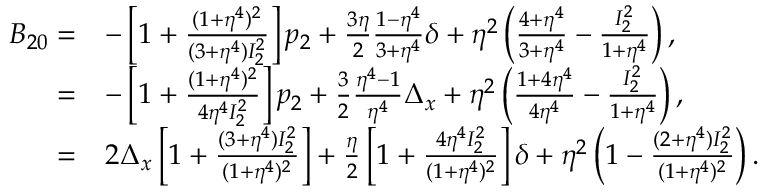Convert formula to latex. <formula><loc_0><loc_0><loc_500><loc_500>\begin{array} { r l } { B _ { 2 0 } = } & { - \left [ 1 + \frac { ( 1 + \eta ^ { 4 } ) ^ { 2 } } { ( 3 + \eta ^ { 4 } ) I _ { 2 } ^ { 2 } } \right ] p _ { 2 } + \frac { 3 \eta } { 2 } \frac { 1 - \eta ^ { 4 } } { 3 + \eta ^ { 4 } } \delta + \eta ^ { 2 } \left ( \frac { 4 + \eta ^ { 4 } } { 3 + \eta ^ { 4 } } - \frac { I _ { 2 } ^ { 2 } } { 1 + \eta ^ { 4 } } \right ) , } \\ { = } & { - \left [ 1 + \frac { ( 1 + \eta ^ { 4 } ) ^ { 2 } } { 4 \eta ^ { 4 } I _ { 2 } ^ { 2 } } \right ] p _ { 2 } + \frac { 3 } { 2 } \frac { \eta ^ { 4 } - 1 } { \eta ^ { 4 } } \Delta _ { x } + \eta ^ { 2 } \left ( \frac { 1 + 4 \eta ^ { 4 } } { 4 \eta ^ { 4 } } - \frac { I _ { 2 } ^ { 2 } } { 1 + \eta ^ { 4 } } \right ) , } \\ { = } & { 2 \Delta _ { x } \left [ 1 + \frac { ( 3 + \eta ^ { 4 } ) I _ { 2 } ^ { 2 } } { ( 1 + \eta ^ { 4 } ) ^ { 2 } } \right ] + \frac { \eta } { 2 } \left [ 1 + \frac { 4 \eta ^ { 4 } I _ { 2 } ^ { 2 } } { ( 1 + \eta ^ { 4 } ) ^ { 2 } } \right ] \delta + \eta ^ { 2 } \left ( 1 - \frac { ( 2 + \eta ^ { 4 } ) I _ { 2 } ^ { 2 } } { ( 1 + \eta ^ { 4 } ) ^ { 2 } } \right ) . } \end{array}</formula> 